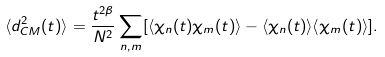<formula> <loc_0><loc_0><loc_500><loc_500>\langle d _ { C M } ^ { 2 } ( t ) \rangle = \frac { t ^ { 2 \beta } } { N ^ { 2 } } \sum _ { n , m } [ \langle \chi _ { n } ( t ) \chi _ { m } ( t ) \rangle - \langle \chi _ { n } ( t ) \rangle \langle \chi _ { m } ( t ) \rangle ] .</formula> 